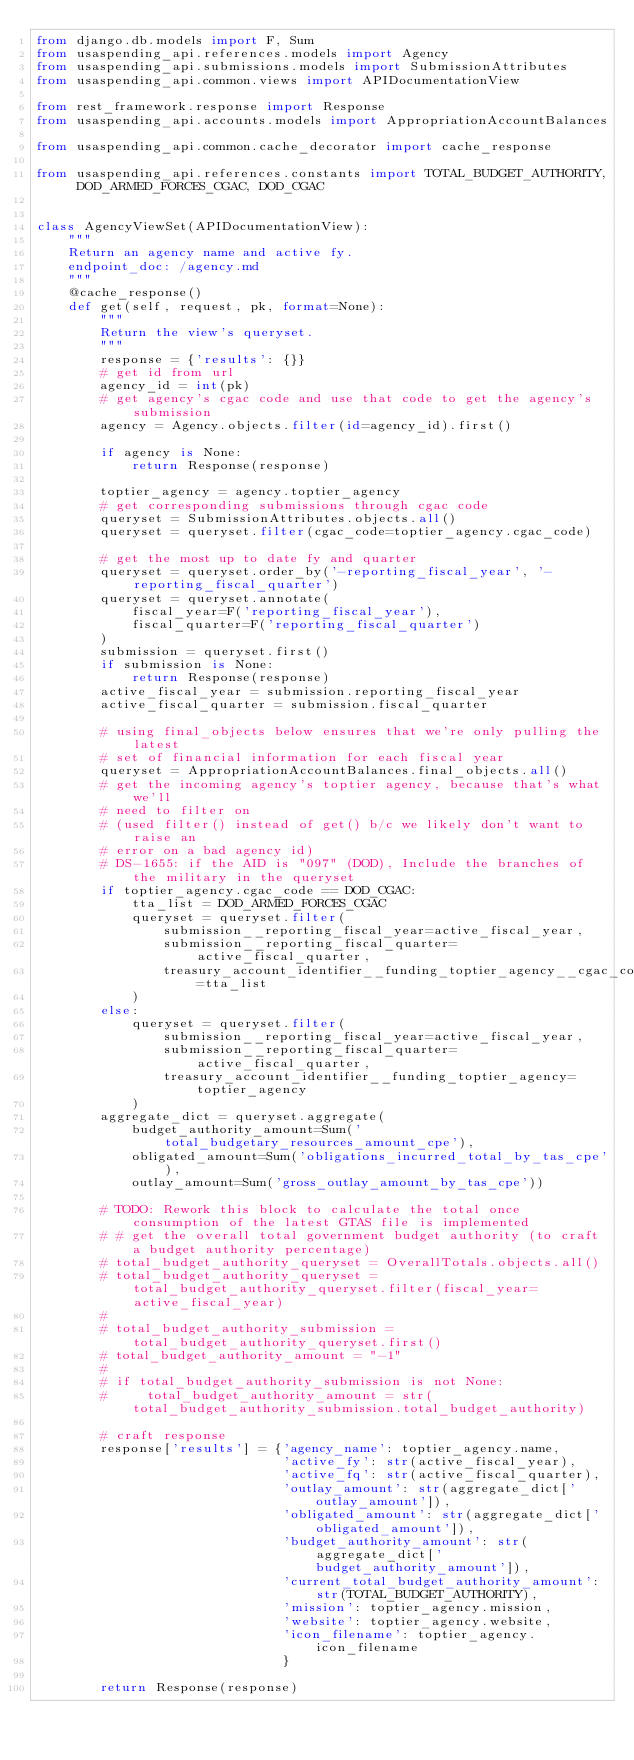<code> <loc_0><loc_0><loc_500><loc_500><_Python_>from django.db.models import F, Sum
from usaspending_api.references.models import Agency
from usaspending_api.submissions.models import SubmissionAttributes
from usaspending_api.common.views import APIDocumentationView

from rest_framework.response import Response
from usaspending_api.accounts.models import AppropriationAccountBalances

from usaspending_api.common.cache_decorator import cache_response

from usaspending_api.references.constants import TOTAL_BUDGET_AUTHORITY, DOD_ARMED_FORCES_CGAC, DOD_CGAC


class AgencyViewSet(APIDocumentationView):
    """
    Return an agency name and active fy.
    endpoint_doc: /agency.md
    """
    @cache_response()
    def get(self, request, pk, format=None):
        """
        Return the view's queryset.
        """
        response = {'results': {}}
        # get id from url
        agency_id = int(pk)
        # get agency's cgac code and use that code to get the agency's submission
        agency = Agency.objects.filter(id=agency_id).first()

        if agency is None:
            return Response(response)

        toptier_agency = agency.toptier_agency
        # get corresponding submissions through cgac code
        queryset = SubmissionAttributes.objects.all()
        queryset = queryset.filter(cgac_code=toptier_agency.cgac_code)

        # get the most up to date fy and quarter
        queryset = queryset.order_by('-reporting_fiscal_year', '-reporting_fiscal_quarter')
        queryset = queryset.annotate(
            fiscal_year=F('reporting_fiscal_year'),
            fiscal_quarter=F('reporting_fiscal_quarter')
        )
        submission = queryset.first()
        if submission is None:
            return Response(response)
        active_fiscal_year = submission.reporting_fiscal_year
        active_fiscal_quarter = submission.fiscal_quarter

        # using final_objects below ensures that we're only pulling the latest
        # set of financial information for each fiscal year
        queryset = AppropriationAccountBalances.final_objects.all()
        # get the incoming agency's toptier agency, because that's what we'll
        # need to filter on
        # (used filter() instead of get() b/c we likely don't want to raise an
        # error on a bad agency id)
        # DS-1655: if the AID is "097" (DOD), Include the branches of the military in the queryset
        if toptier_agency.cgac_code == DOD_CGAC:
            tta_list = DOD_ARMED_FORCES_CGAC
            queryset = queryset.filter(
                submission__reporting_fiscal_year=active_fiscal_year,
                submission__reporting_fiscal_quarter=active_fiscal_quarter,
                treasury_account_identifier__funding_toptier_agency__cgac_code__in=tta_list
            )
        else:
            queryset = queryset.filter(
                submission__reporting_fiscal_year=active_fiscal_year,
                submission__reporting_fiscal_quarter=active_fiscal_quarter,
                treasury_account_identifier__funding_toptier_agency=toptier_agency
            )
        aggregate_dict = queryset.aggregate(
            budget_authority_amount=Sum('total_budgetary_resources_amount_cpe'),
            obligated_amount=Sum('obligations_incurred_total_by_tas_cpe'),
            outlay_amount=Sum('gross_outlay_amount_by_tas_cpe'))

        # TODO: Rework this block to calculate the total once consumption of the latest GTAS file is implemented
        # # get the overall total government budget authority (to craft a budget authority percentage)
        # total_budget_authority_queryset = OverallTotals.objects.all()
        # total_budget_authority_queryset = total_budget_authority_queryset.filter(fiscal_year=active_fiscal_year)
        #
        # total_budget_authority_submission = total_budget_authority_queryset.first()
        # total_budget_authority_amount = "-1"
        #
        # if total_budget_authority_submission is not None:
        #     total_budget_authority_amount = str(total_budget_authority_submission.total_budget_authority)

        # craft response
        response['results'] = {'agency_name': toptier_agency.name,
                               'active_fy': str(active_fiscal_year),
                               'active_fq': str(active_fiscal_quarter),
                               'outlay_amount': str(aggregate_dict['outlay_amount']),
                               'obligated_amount': str(aggregate_dict['obligated_amount']),
                               'budget_authority_amount': str(aggregate_dict['budget_authority_amount']),
                               'current_total_budget_authority_amount': str(TOTAL_BUDGET_AUTHORITY),
                               'mission': toptier_agency.mission,
                               'website': toptier_agency.website,
                               'icon_filename': toptier_agency.icon_filename
                               }

        return Response(response)
</code> 